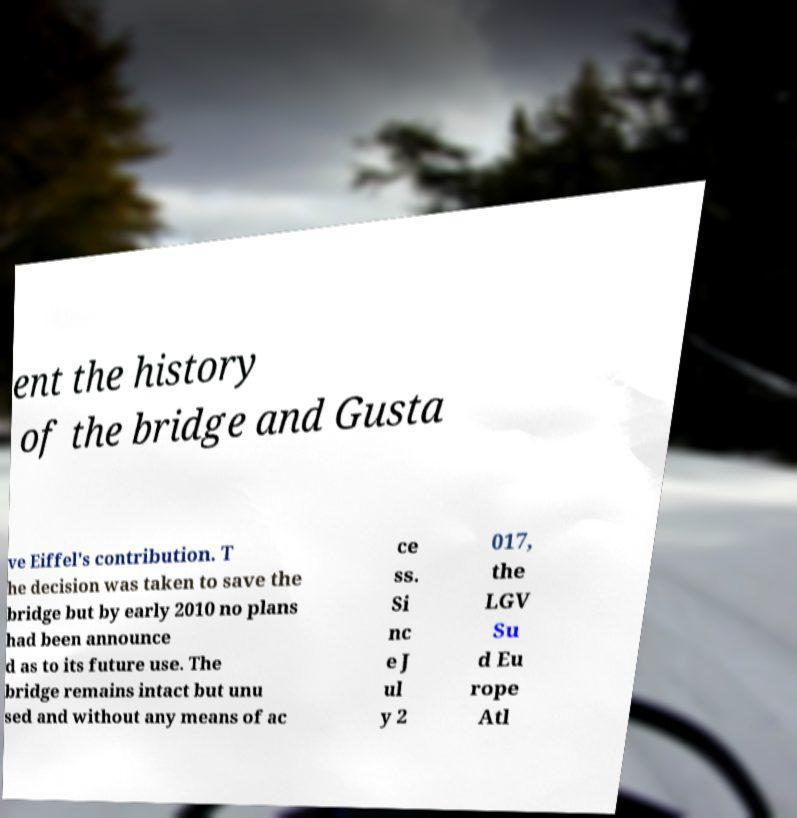Could you extract and type out the text from this image? ent the history of the bridge and Gusta ve Eiffel's contribution. T he decision was taken to save the bridge but by early 2010 no plans had been announce d as to its future use. The bridge remains intact but unu sed and without any means of ac ce ss. Si nc e J ul y 2 017, the LGV Su d Eu rope Atl 